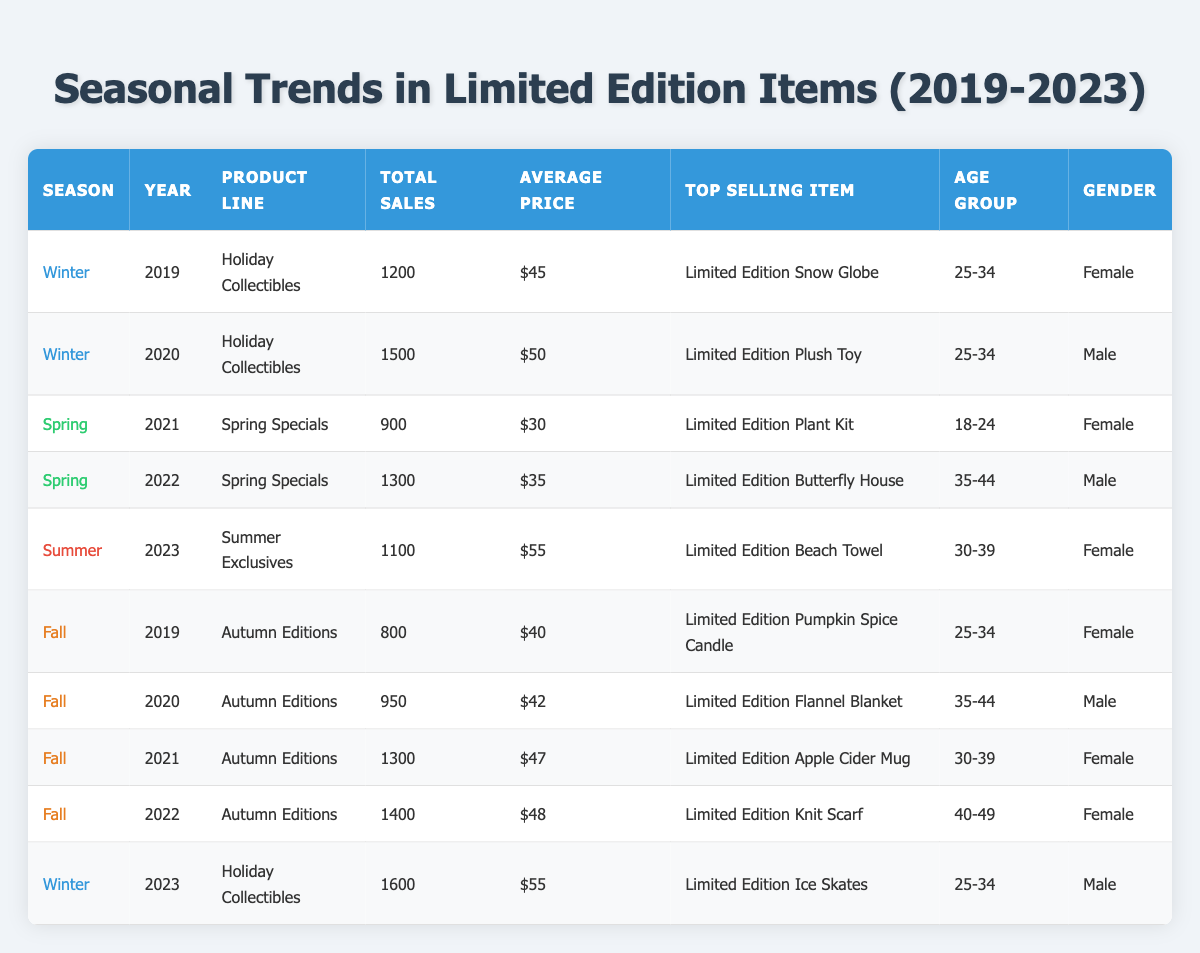What was the top-selling item in Winter 2020? In the row for Winter 2020, the top-selling item listed is the "Limited Edition Plush Toy."
Answer: Limited Edition Plush Toy How many total sales were recorded in Fall 2022? In the row for Fall 2022, the total sales recorded are 1400.
Answer: 1400 What is the average price of items sold in Spring over the years? The average prices in Spring are $30 (2021) and $35 (2022). To find the average: (30 + 35) / 2 = 32.5
Answer: 32.5 Which season had the highest total sales in 2023? The only sales data for 2023 is for Winter with 1600 total sales. Therefore, Winter had the highest sales for that year.
Answer: Winter Was the top-selling item in Fall 2021 a female-targeted demographic? The top-selling item for Fall 2021 is the "Limited Edition Apple Cider Mug," and the demographic is female (30-39). Thus, it is female-targeted.
Answer: Yes How many total sales were there for all seasons in 2019? The total sales in 2019 are the sum of Winter (1200) and Fall (800), which is 1200 + 800 = 2000.
Answer: 2000 Which season had the highest average price for limited edition items? By examining the average prices across all seasons, Winter 2023 has the highest at $55.
Answer: Winter 2023 What was the total sales difference between Spring 2021 and Spring 2022? The total sales for Spring 2021 is 900, and for Spring 2022 is 1300. The difference is 1300 - 900 = 400.
Answer: 400 What product line was the top-selling item during Winter 2023? The row for Winter 2023 indicates that the product line with the top-selling item "Limited Edition Ice Skates" is "Holiday Collectibles."
Answer: Holiday Collectibles Did any male customers purchase items in Fall 2020? The row for Fall 2020 shows that the top-selling item was bought by a male customer, specifically in the age group 35-44.
Answer: Yes 